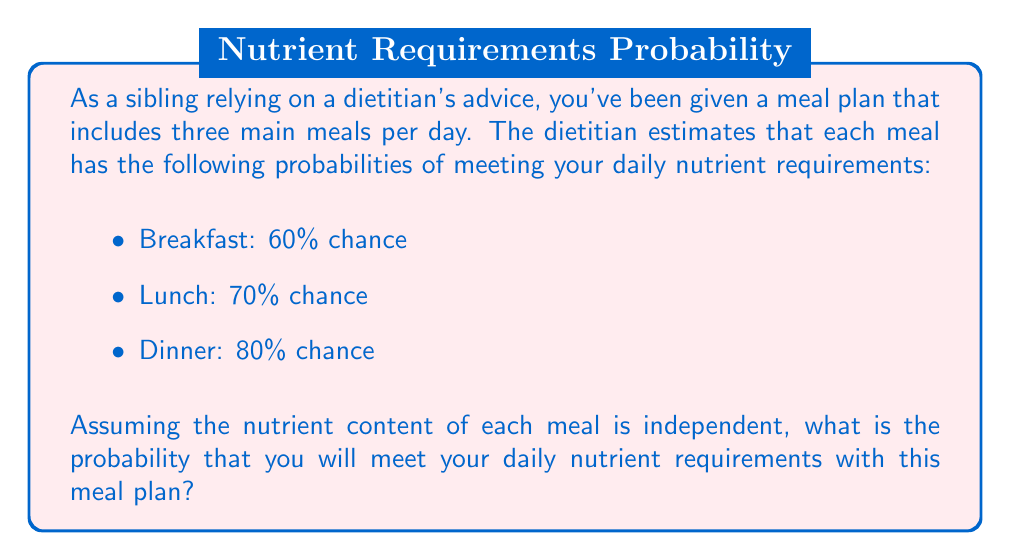Give your solution to this math problem. To solve this problem, we need to calculate the probability of meeting the daily nutrient requirements, which is equivalent to the probability of not failing to meet the requirements in all three meals.

Let's approach this step-by-step:

1. First, let's calculate the probability of not meeting the requirements for each meal:
   - Breakfast: $1 - 0.60 = 0.40$ or $40\%$
   - Lunch: $1 - 0.70 = 0.30$ or $30\%$
   - Dinner: $1 - 0.80 = 0.20$ or $20\%$

2. The probability of failing to meet the requirements in all three meals is the product of these individual probabilities:

   $$P(\text{fail all}) = 0.40 \times 0.30 \times 0.20 = 0.024 \text{ or } 2.4\%$$

3. Therefore, the probability of meeting the daily requirements is the complement of this probability:

   $$P(\text{meet requirements}) = 1 - P(\text{fail all}) = 1 - 0.024 = 0.976$$

This can also be calculated directly:

$$P(\text{meet requirements}) = 1 - [(1-0.60) \times (1-0.70) \times (1-0.80)]$$

$$= 1 - [0.40 \times 0.30 \times 0.20]$$

$$= 1 - 0.024 = 0.976$$
Answer: The probability of meeting the daily nutrient requirements with the given meal plan is $0.976$ or $97.6\%$. 